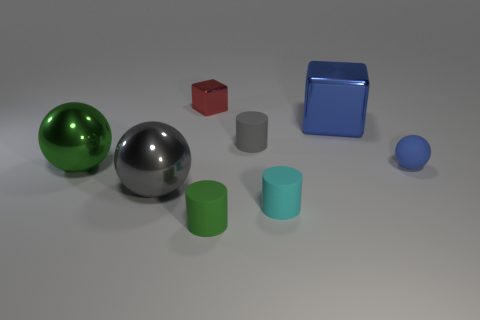Add 2 tiny cyan rubber things. How many objects exist? 10 Subtract all cylinders. How many objects are left? 5 Subtract all gray spheres. Subtract all small cylinders. How many objects are left? 4 Add 3 small metallic objects. How many small metallic objects are left? 4 Add 1 large yellow matte blocks. How many large yellow matte blocks exist? 1 Subtract 1 red blocks. How many objects are left? 7 